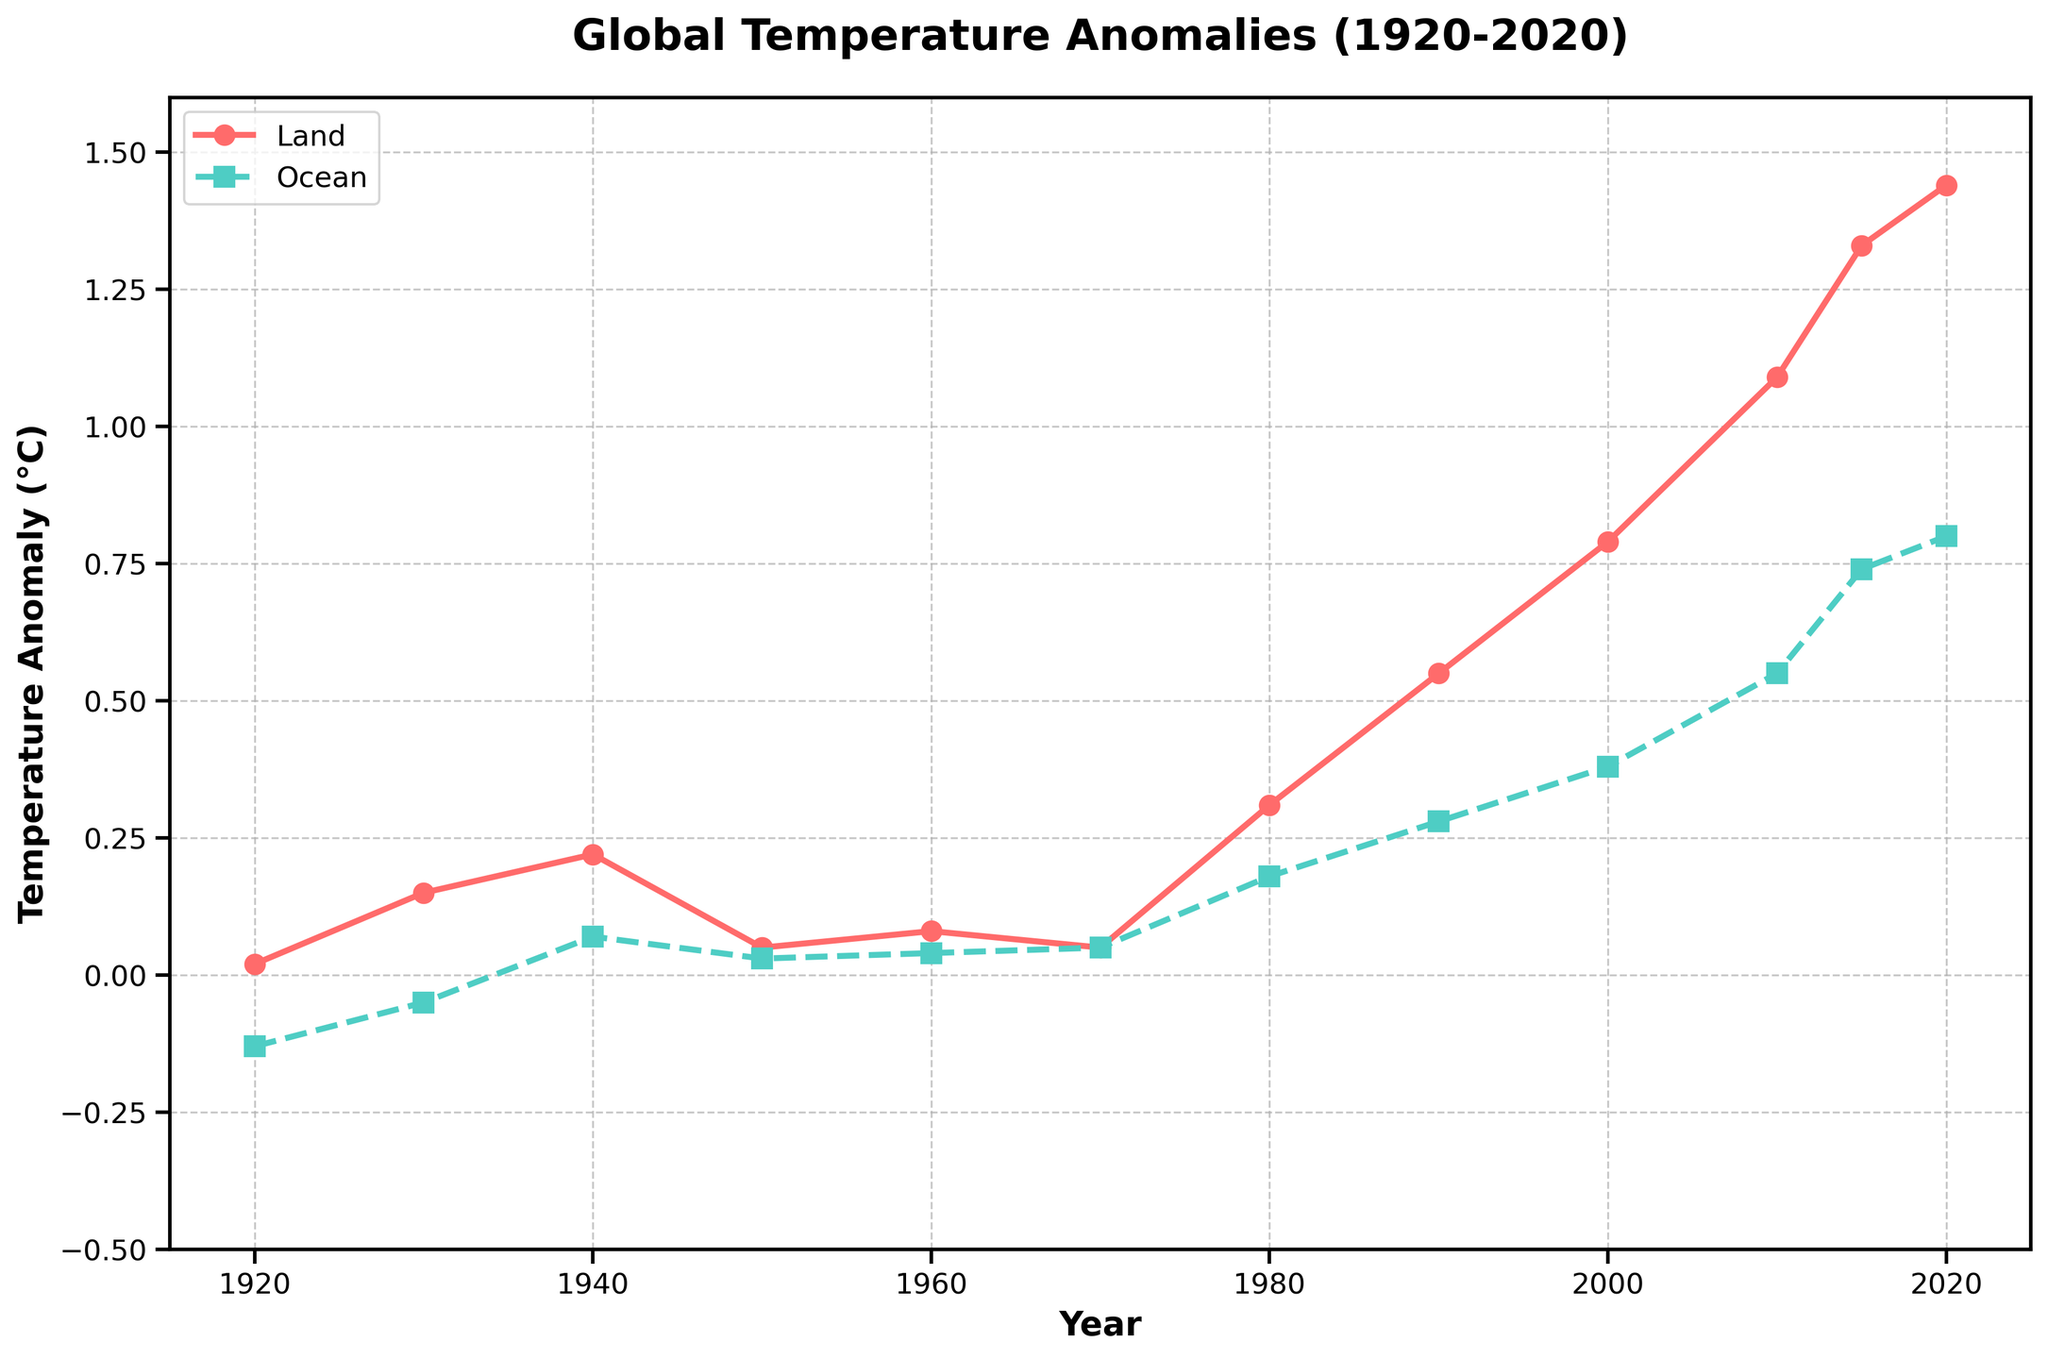What is the overall trend observed for both land and ocean temperature anomalies from 1920 to 2020? The overall trend for both land and ocean temperature anomalies is an upward trend. Land temperatures have increased more rapidly than ocean temperatures over this period.
Answer: Upward trend When did the land temperature anomaly surpass 1°C? According to the line plot, the land temperature anomaly surpassed 1°C around 2010.
Answer: Around 2010 Which year shows the highest land temperature anomaly in the chart? The highest land temperature anomaly shown in the chart is in the year 2020.
Answer: 2020 What is the difference between land and ocean temperature anomalies in 1980? To find the difference, subtract the ocean temperature anomaly from the land temperature anomaly in 1980: 0.31 (land) - 0.18 (ocean) = 0.13.
Answer: 0.13°C Between which decades did the steepest increase in land temperature anomalies occur? The steepest increase in land temperature anomalies occurred between the 1990s and 2000s, where the anomaly increased from 0.55°C to 0.79°C.
Answer: 1990s to 2000s Compare the land and ocean temperature anomaly trends from 1950 to 1970. From 1950 to 1970, both land and ocean temperature anomalies showed minimal change and remained relatively stable.
Answer: Relatively stable In which year did the ocean temperature anomaly first exceed 0.5°C? The ocean temperature anomaly first exceeded 0.5°C around the year 2010.
Answer: Around 2010 What are the land and ocean temperature anomalies for the year 1940, and what is their average? The land temperature anomaly for 1940 is 0.22°C, and the ocean temperature anomaly is 0.07°C. Average: (0.22 + 0.07) / 2 = 0.145°C.
Answer: 0.145°C Which year shows the smallest gap between land and ocean temperature anomalies? The year 1970 shows the smallest gap between land (0.05°C) and ocean (0.05°C) temperature anomalies.
Answer: 1970 